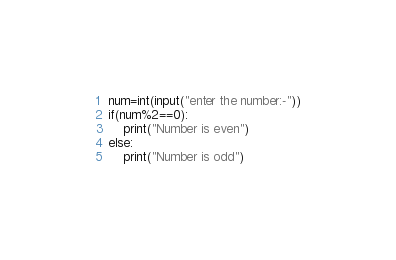Convert code to text. <code><loc_0><loc_0><loc_500><loc_500><_Python_>num=int(input("enter the number:-"))
if(num%2==0):
    print("Number is even")
else:
    print("Number is odd")</code> 